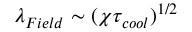Convert formula to latex. <formula><loc_0><loc_0><loc_500><loc_500>\lambda _ { F i e l d } \sim ( \chi \tau _ { c o o l } ) ^ { 1 / 2 }</formula> 